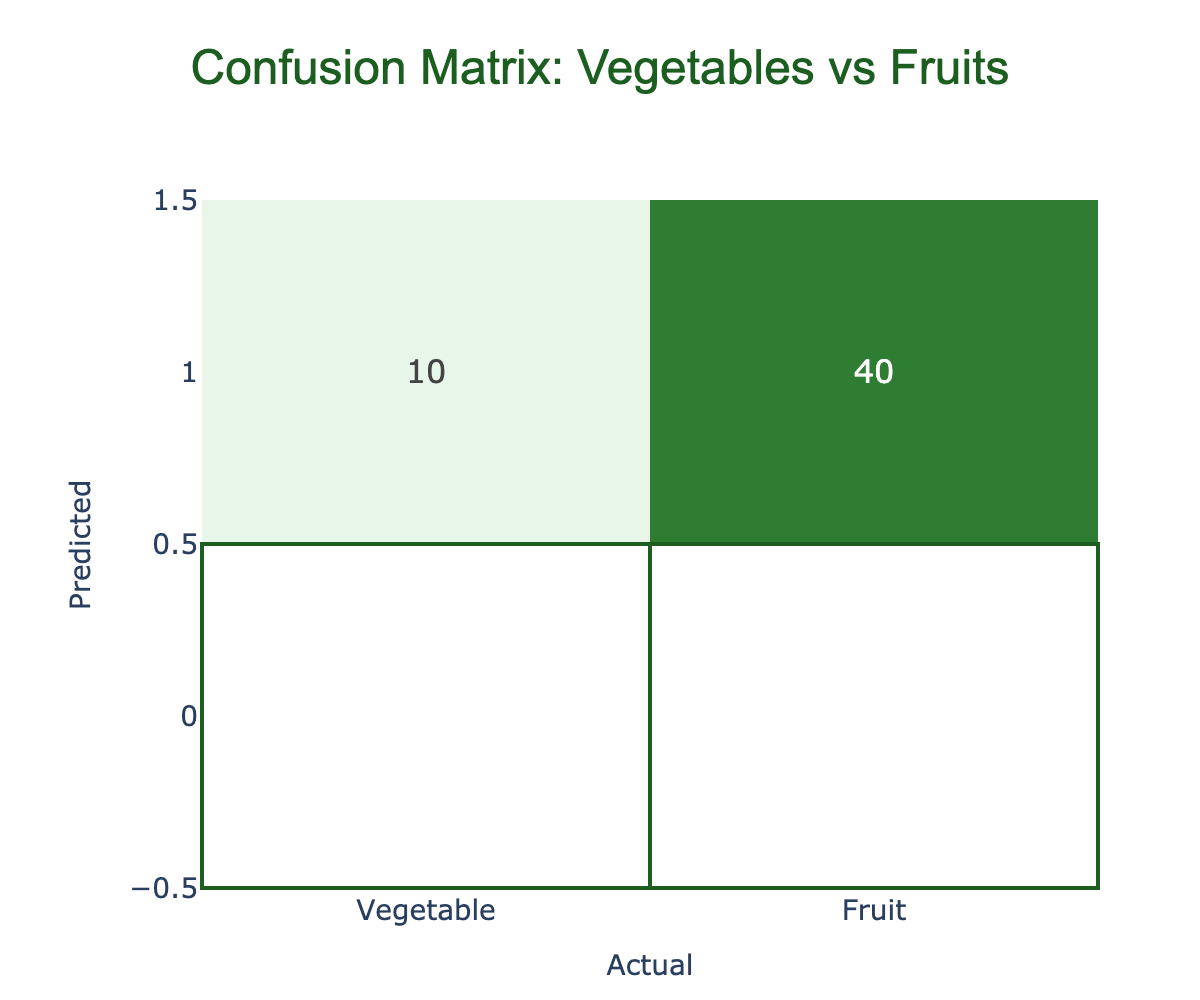What is the number of vegetables classified correctly? In the confusion matrix, the cell where the predicted value is "Vegetable" and the actual value is "Vegetable" shows a count of 45. This indicates that 45 vegetables were classified correctly.
Answer: 45 How many fruits were misclassified as vegetables? In the confusion matrix, the cell where the predicted value is "Vegetable" and the actual value is "Fruit" shows a count of 10. This represents the number of fruits that were incorrectly classified as vegetables.
Answer: 10 What is the total number of items that were classified as fruits? To find the total classified as fruits, we sum the counts in the "Fruit" column: correct classifications (40) plus misclassifications (10) gives us 40 + 10 = 50.
Answer: 50 What is the overall accuracy of the classification? The overall accuracy is calculated by taking the number of correct predictions (45 vegetables + 40 fruits = 85) and dividing it by the total number of predictions (45 + 5 + 10 + 40 = 100) which results in 85/100 = 0.85 or 85%.
Answer: 85% Are there more vegetables correctly classified than fruits? From the table, the correct classification for vegetables is 45 and for fruits, it’s 40. Since 45 is greater than 40, the statement is true.
Answer: Yes What is the total number of misclassifications? To find the total misclassifications, we sum the counts of misclassified vegetables (5) and misclassified fruits (10) which results in 5 + 10 = 15.
Answer: 15 What percentage of vegetables were misclassified? To find the percentage, we take the number of misclassified vegetables (5) and divide it by the total number of actual vegetables (45 + 5 = 50) and then multiply by 100, which gives (5/50) * 100 = 10%.
Answer: 10% What is the difference between the number of correct classifications for vegetables and the number of correct classifications for fruits? The difference can be found by subtracting the number of correctly classified fruits (40) from the number of correctly classified vegetables (45). Thus, 45 - 40 = 5.
Answer: 5 How many times was a vegetable predicted when the actual item was a fruit? In the confusion matrix, the count of vegetables predicted when the actual item was a fruit is given as 10. This indicates the number of instances where fruits were incorrectly identified as vegetables.
Answer: 10 